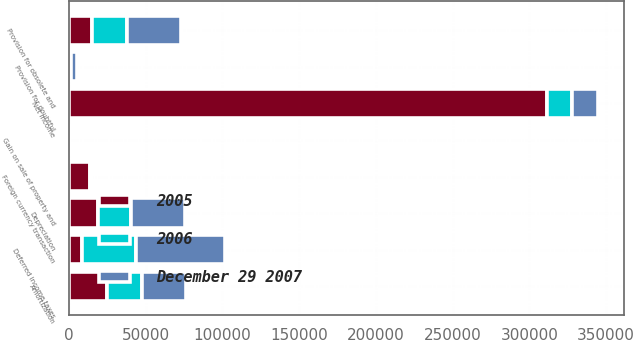Convert chart. <chart><loc_0><loc_0><loc_500><loc_500><stacked_bar_chart><ecel><fcel>Net income<fcel>Depreciation<fcel>Amortization<fcel>Gain on sale of property and<fcel>Provision for doubtful<fcel>Provision for obsolete and<fcel>Foreign currency transaction<fcel>Deferred income taxes<nl><fcel>December 29 2007<fcel>16724<fcel>35524<fcel>28513<fcel>560<fcel>3617<fcel>34975<fcel>926<fcel>57843<nl><fcel>2006<fcel>16724<fcel>21535<fcel>22940<fcel>67<fcel>955<fcel>23245<fcel>344<fcel>35060<nl><fcel>2005<fcel>311219<fcel>18693<fcel>24903<fcel>37<fcel>445<fcel>14755<fcel>13957<fcel>8833<nl></chart> 